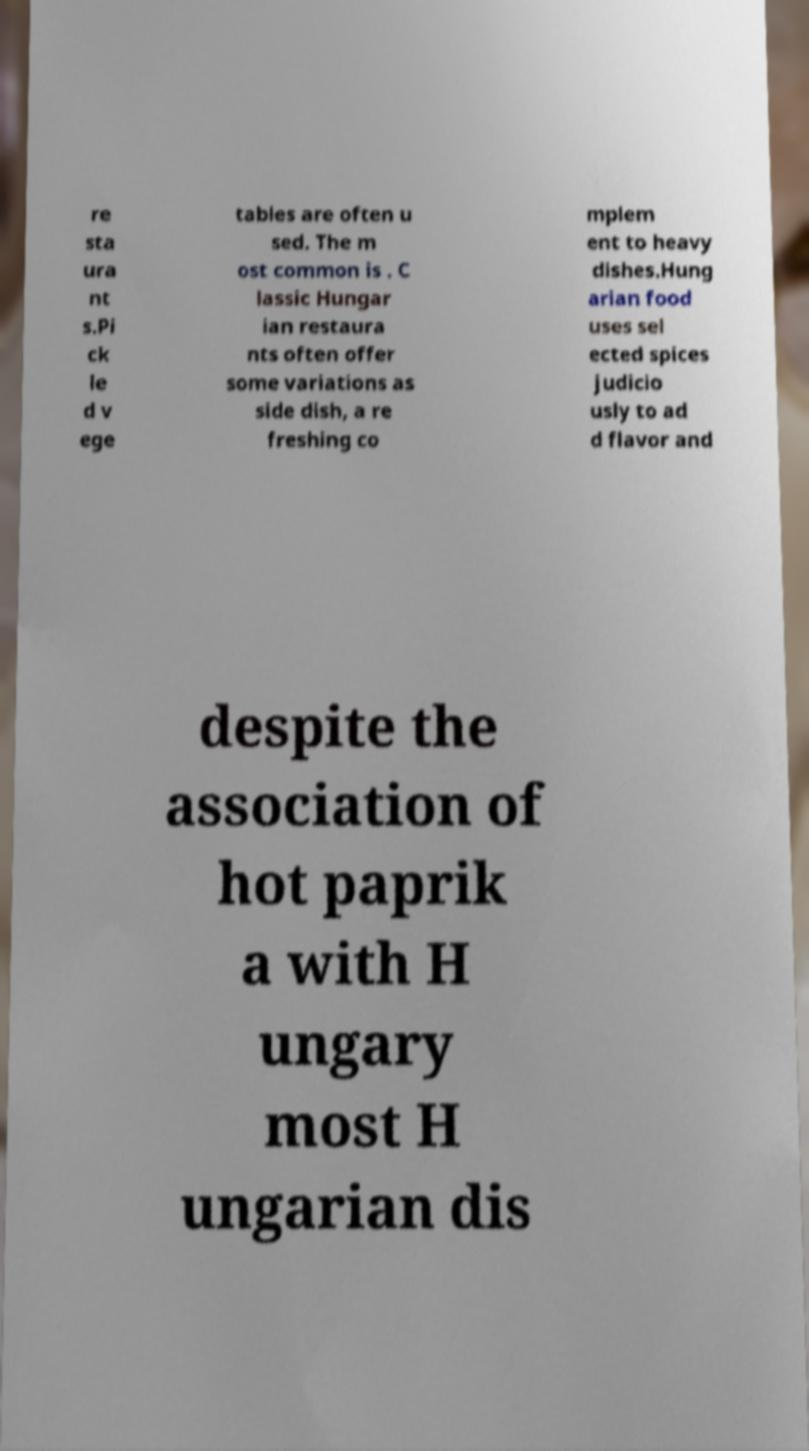Could you assist in decoding the text presented in this image and type it out clearly? re sta ura nt s.Pi ck le d v ege tables are often u sed. The m ost common is . C lassic Hungar ian restaura nts often offer some variations as side dish, a re freshing co mplem ent to heavy dishes.Hung arian food uses sel ected spices judicio usly to ad d flavor and despite the association of hot paprik a with H ungary most H ungarian dis 